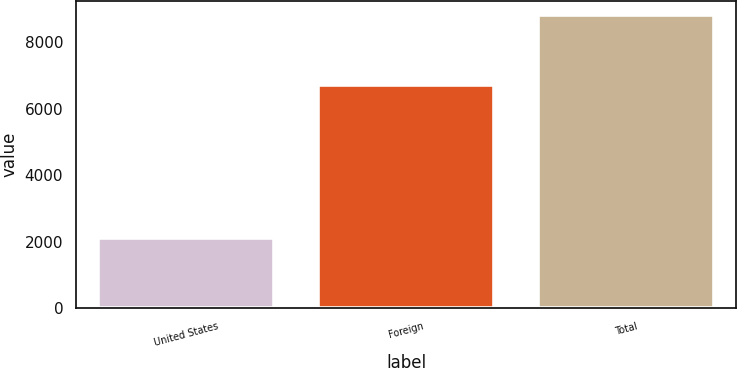<chart> <loc_0><loc_0><loc_500><loc_500><bar_chart><fcel>United States<fcel>Foreign<fcel>Total<nl><fcel>2112<fcel>6706<fcel>8818<nl></chart> 